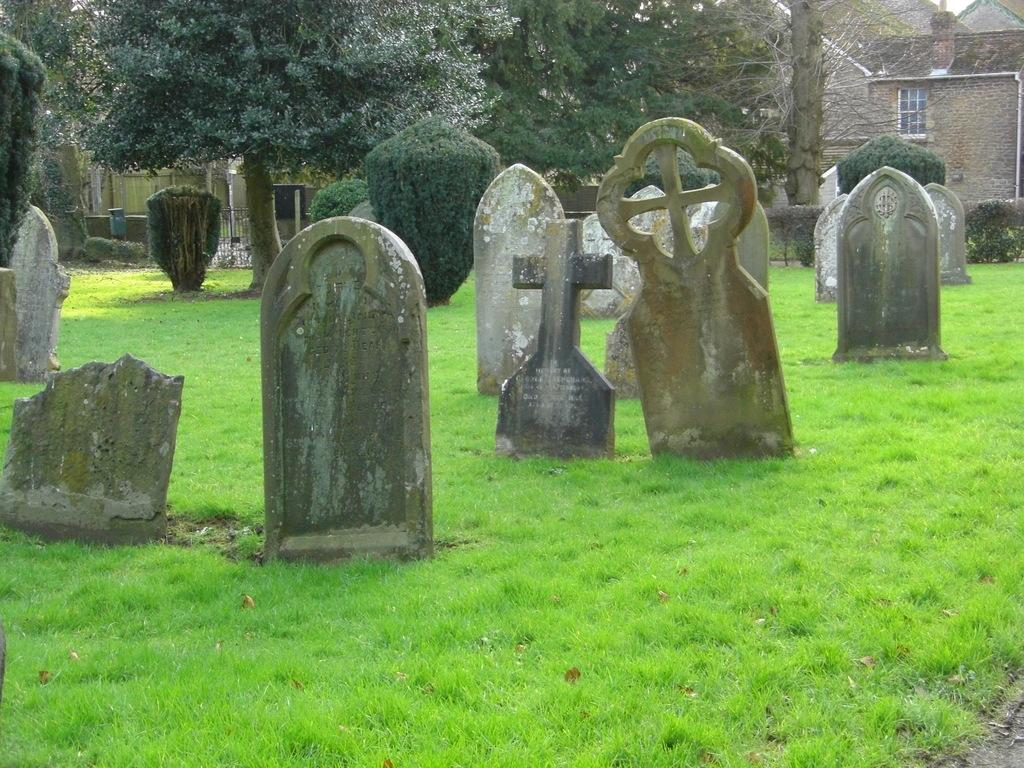What type of structures can be seen in the image? There are houses in the image. What other elements are present in the image besides the houses? There are graves, plants, trees, and grass visible in the image. Can you describe the natural elements in the image? There are plants, trees, and grass visible in the image. How does the person in the image whistle while touching the plants? There is no person present in the image, and therefore no one is whistling or touching the plants. 